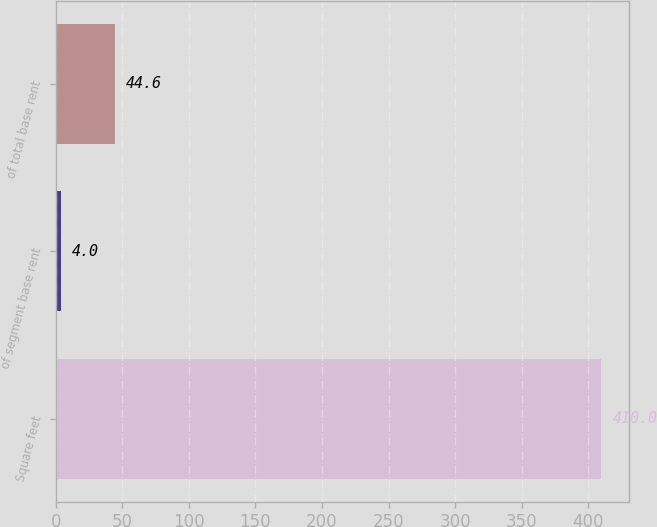<chart> <loc_0><loc_0><loc_500><loc_500><bar_chart><fcel>Square feet<fcel>of segment base rent<fcel>of total base rent<nl><fcel>410<fcel>4<fcel>44.6<nl></chart> 